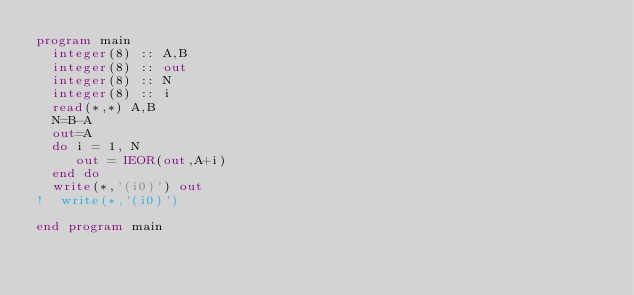Convert code to text. <code><loc_0><loc_0><loc_500><loc_500><_FORTRAN_>program main
  integer(8) :: A,B
  integer(8) :: out
  integer(8) :: N
  integer(8) :: i
  read(*,*) A,B
  N=B-A
  out=A
  do i = 1, N
     out = IEOR(out,A+i)
  end do
  write(*,'(i0)') out
!  write(*,'(i0)')

end program main
  </code> 